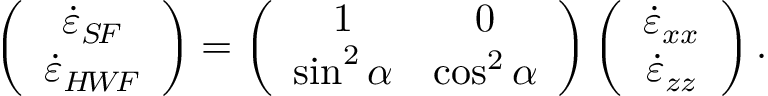Convert formula to latex. <formula><loc_0><loc_0><loc_500><loc_500>\left ( \begin{array} { c } { \dot { \varepsilon } _ { S \, F } } \\ { \dot { \varepsilon } _ { H \, W \, F } } \end{array} \right ) = \left ( \begin{array} { c c } { 1 } & { 0 } \\ { \sin ^ { 2 } \alpha } & { \cos ^ { 2 } \alpha } \end{array} \right ) \left ( \begin{array} { c } { \dot { \varepsilon } _ { x x } } \\ { \dot { \varepsilon } _ { z z } } \end{array} \right ) .</formula> 